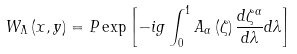<formula> <loc_0><loc_0><loc_500><loc_500>W _ { \Lambda } \left ( { x , y } \right ) = P \exp \left [ { - i g \int _ { 0 } ^ { 1 } { A _ { \alpha } \left ( \zeta \right ) \frac { d \zeta ^ { \alpha } } { d \lambda } d \lambda } } \right ]</formula> 